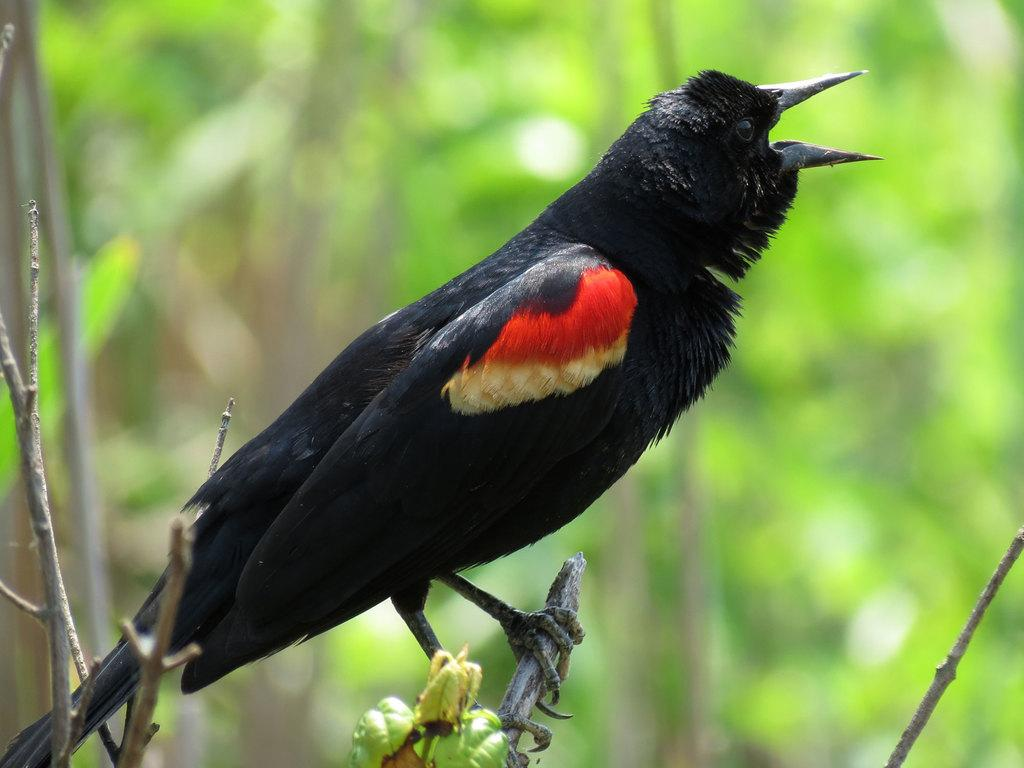What type of animal is in the image? There is a bird in the image. Where is the bird located? The bird is on a branch. What can be seen in the background of the image? There are trees in the background of the image. How would you describe the background of the image? The background is blurry. What type of substance is the bird using to build its home in the image? There is no indication in the image that the bird is building a home, nor is there any substance visible for that purpose. 